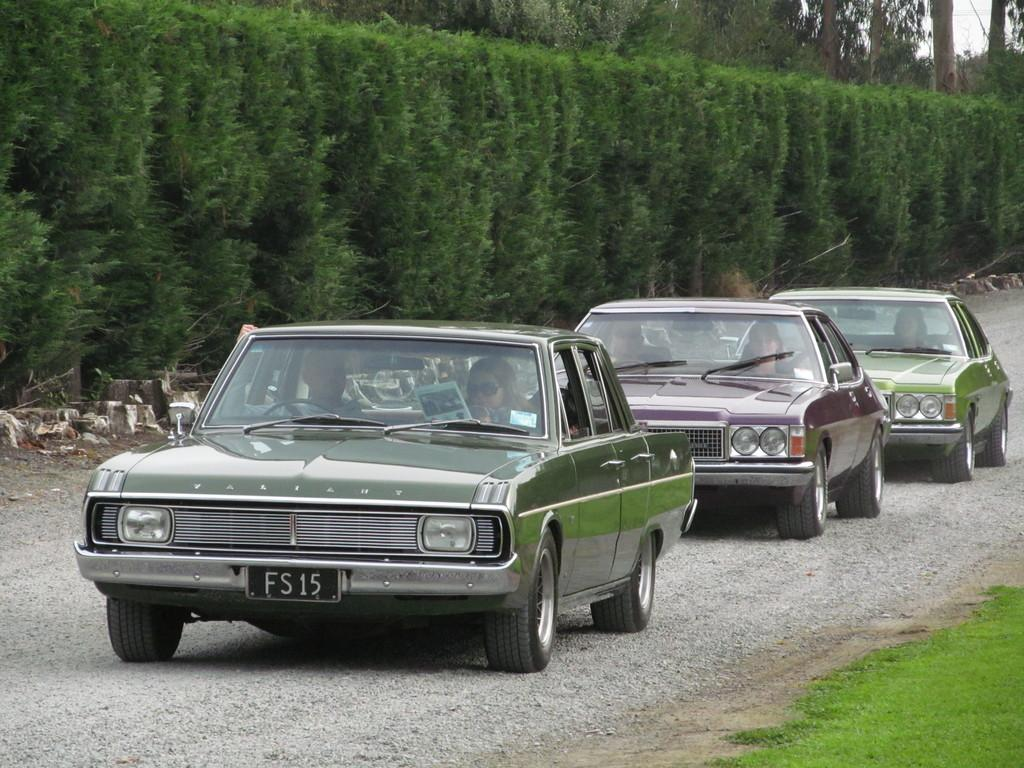What can be seen moving on the road in the image? There are cars on the road in the image. What type of vegetation is visible in the background of the image? There are trees in the background of the image. What type of ground surface is visible at the bottom of the image? There is grass at the bottom of the image. What type of pathway is visible at the bottom of the image? There is a road at the bottom of the image. Can you see a basket being used by the cars in the image? There is no basket present in the image, and it is not being used by the cars. Is there a whistle being blown by any of the trees in the image? There is no whistle being blown by any of the trees in the image. 